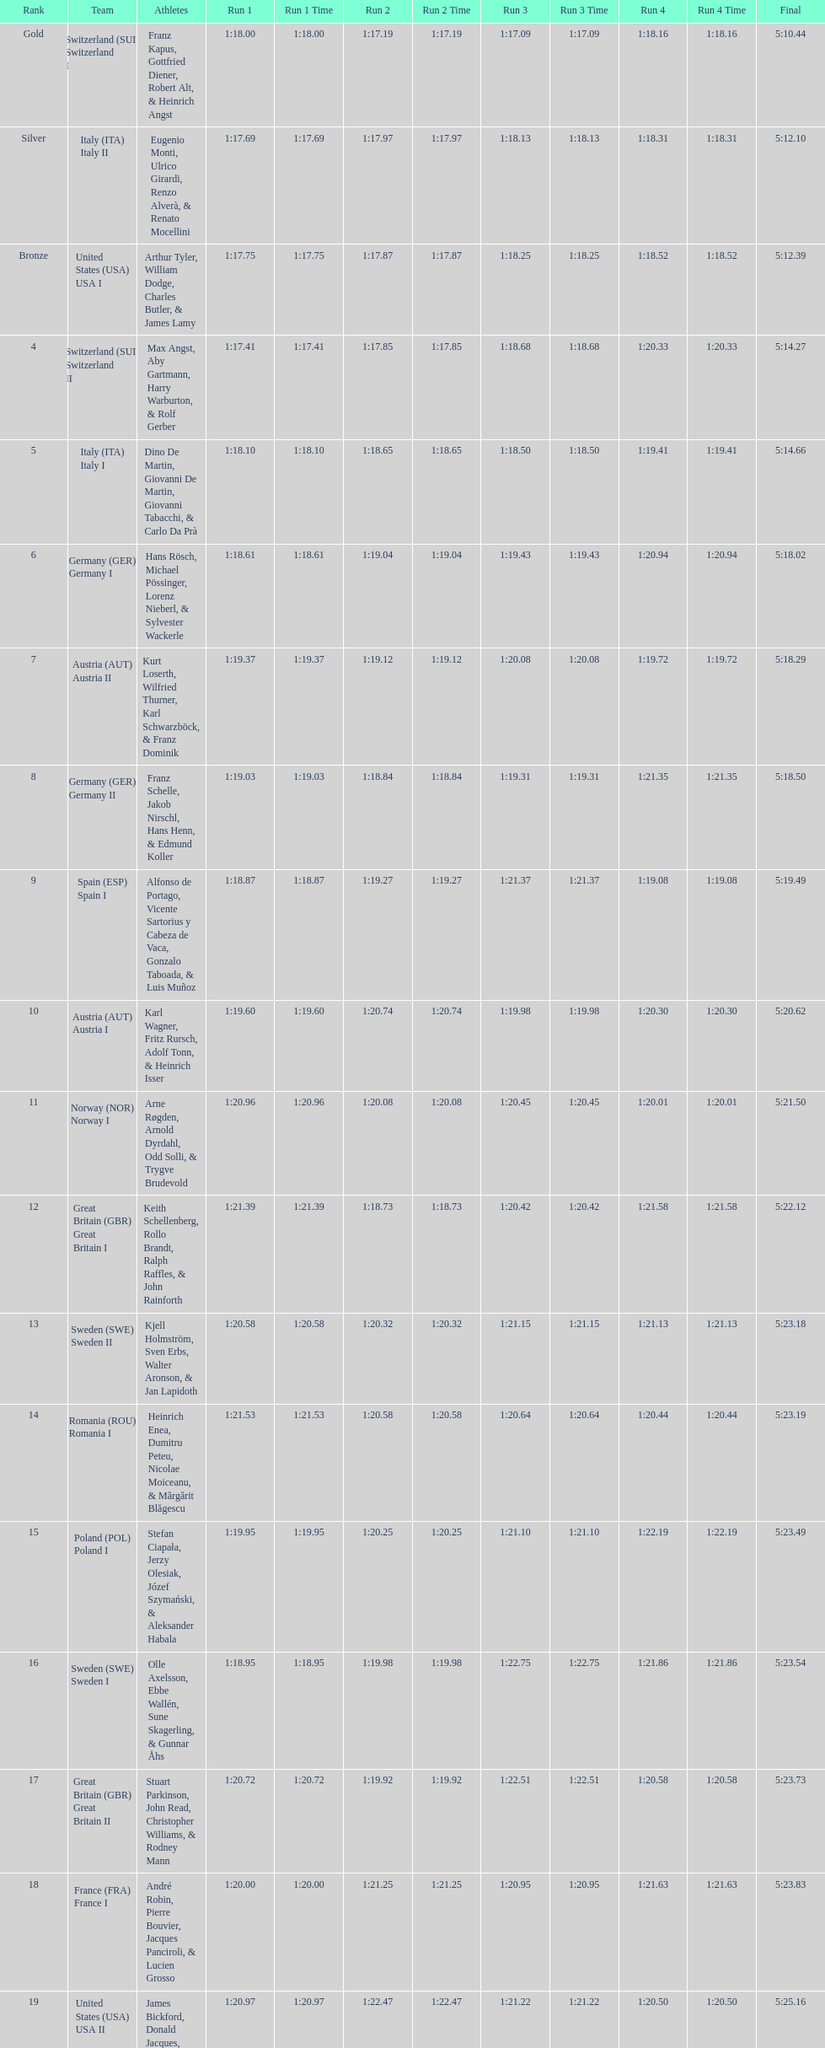What is the total amount of runs? 4. 